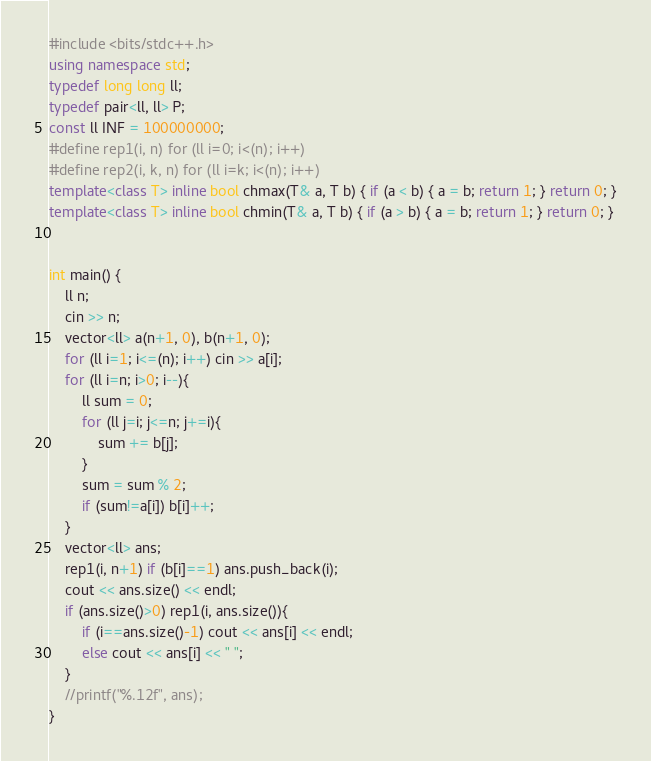<code> <loc_0><loc_0><loc_500><loc_500><_C++_>#include <bits/stdc++.h>
using namespace std;
typedef long long ll;
typedef pair<ll, ll> P;
const ll INF = 100000000;
#define rep1(i, n) for (ll i=0; i<(n); i++) 
#define rep2(i, k, n) for (ll i=k; i<(n); i++)
template<class T> inline bool chmax(T& a, T b) { if (a < b) { a = b; return 1; } return 0; }
template<class T> inline bool chmin(T& a, T b) { if (a > b) { a = b; return 1; } return 0; }


int main() {
    ll n;
    cin >> n;
    vector<ll> a(n+1, 0), b(n+1, 0);
    for (ll i=1; i<=(n); i++) cin >> a[i];
    for (ll i=n; i>0; i--){
        ll sum = 0;
        for (ll j=i; j<=n; j+=i){
            sum += b[j];
        }
        sum = sum % 2;
        if (sum!=a[i]) b[i]++;
    }
    vector<ll> ans;
    rep1(i, n+1) if (b[i]==1) ans.push_back(i);
    cout << ans.size() << endl;
    if (ans.size()>0) rep1(i, ans.size()){
        if (i==ans.size()-1) cout << ans[i] << endl;
        else cout << ans[i] << " ";
    }
    //printf("%.12f", ans);
}</code> 